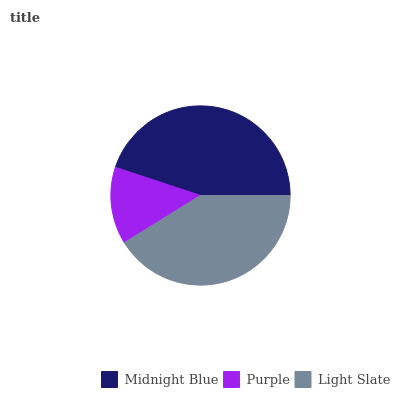Is Purple the minimum?
Answer yes or no. Yes. Is Midnight Blue the maximum?
Answer yes or no. Yes. Is Light Slate the minimum?
Answer yes or no. No. Is Light Slate the maximum?
Answer yes or no. No. Is Light Slate greater than Purple?
Answer yes or no. Yes. Is Purple less than Light Slate?
Answer yes or no. Yes. Is Purple greater than Light Slate?
Answer yes or no. No. Is Light Slate less than Purple?
Answer yes or no. No. Is Light Slate the high median?
Answer yes or no. Yes. Is Light Slate the low median?
Answer yes or no. Yes. Is Midnight Blue the high median?
Answer yes or no. No. Is Midnight Blue the low median?
Answer yes or no. No. 